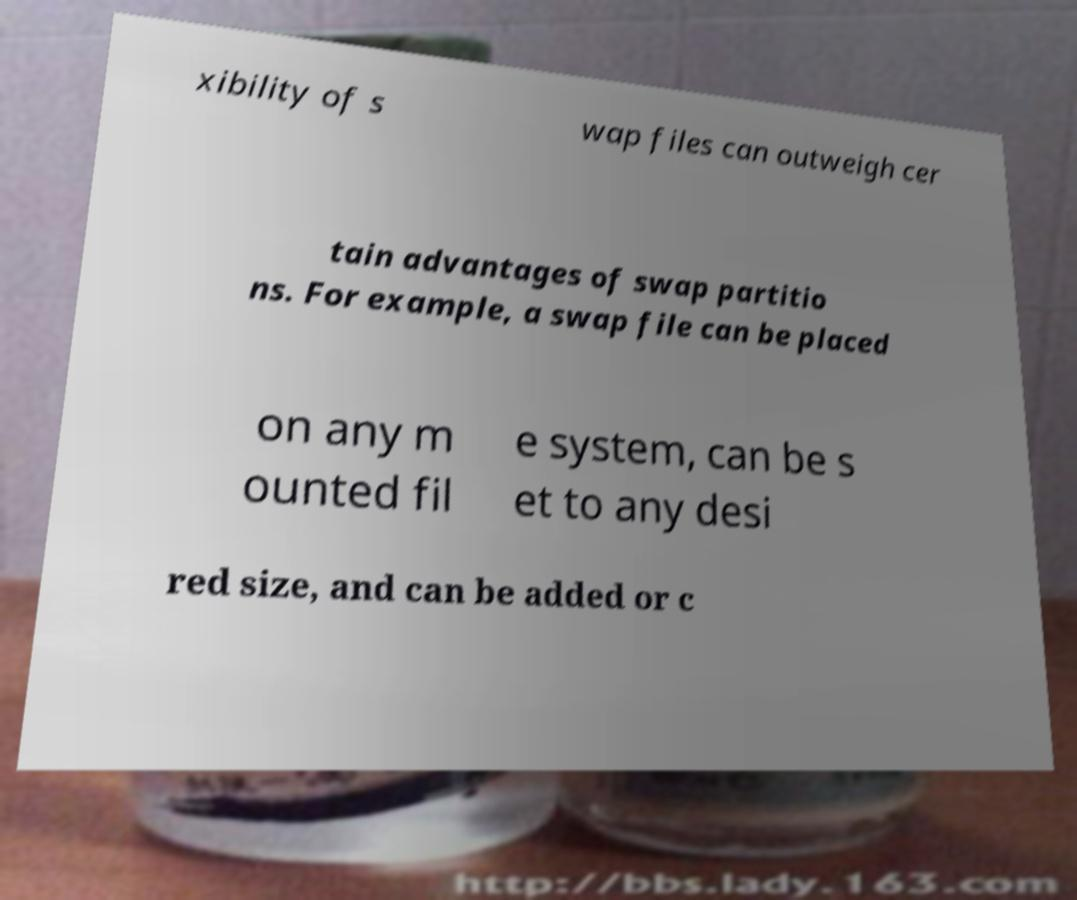Can you read and provide the text displayed in the image?This photo seems to have some interesting text. Can you extract and type it out for me? xibility of s wap files can outweigh cer tain advantages of swap partitio ns. For example, a swap file can be placed on any m ounted fil e system, can be s et to any desi red size, and can be added or c 